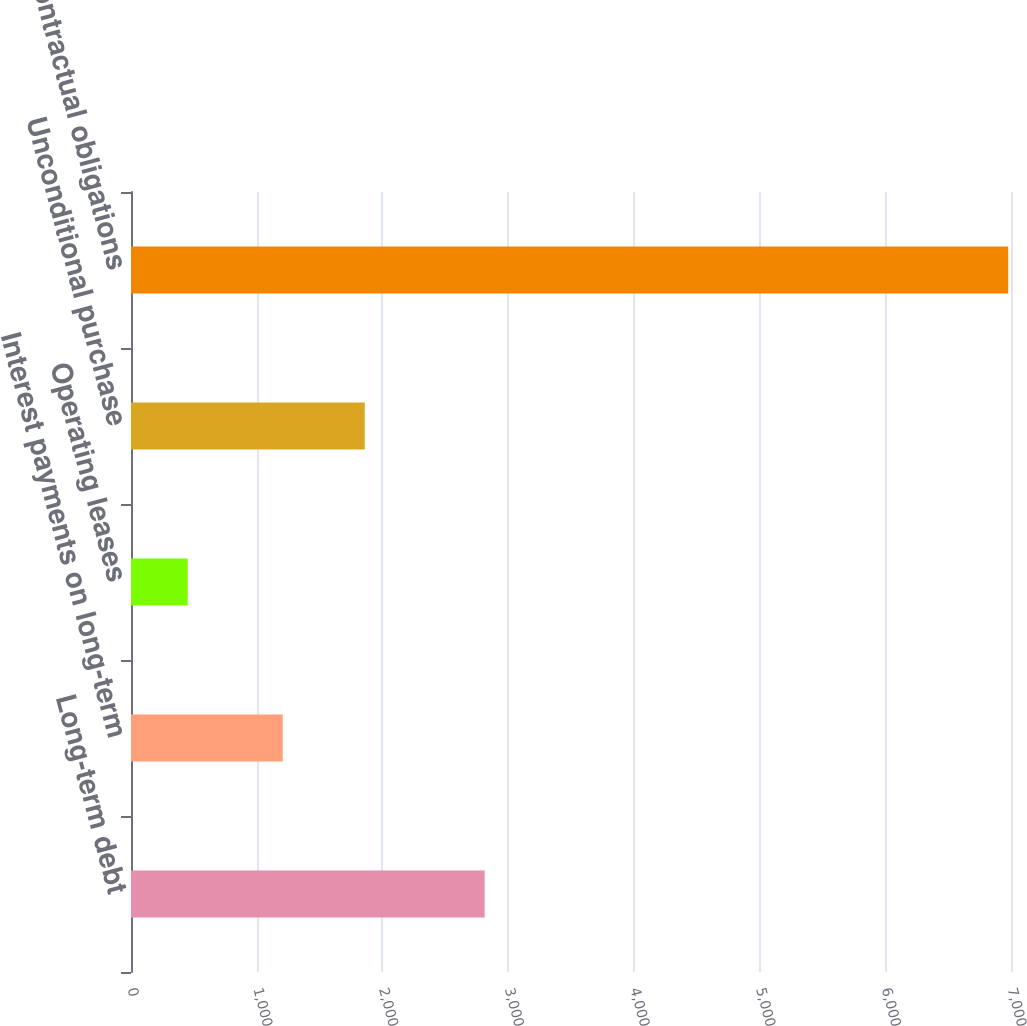<chart> <loc_0><loc_0><loc_500><loc_500><bar_chart><fcel>Long-term debt<fcel>Interest payments on long-term<fcel>Operating leases<fcel>Unconditional purchase<fcel>Total contractual obligations<nl><fcel>2813<fcel>1207<fcel>451<fcel>1859.7<fcel>6978<nl></chart> 